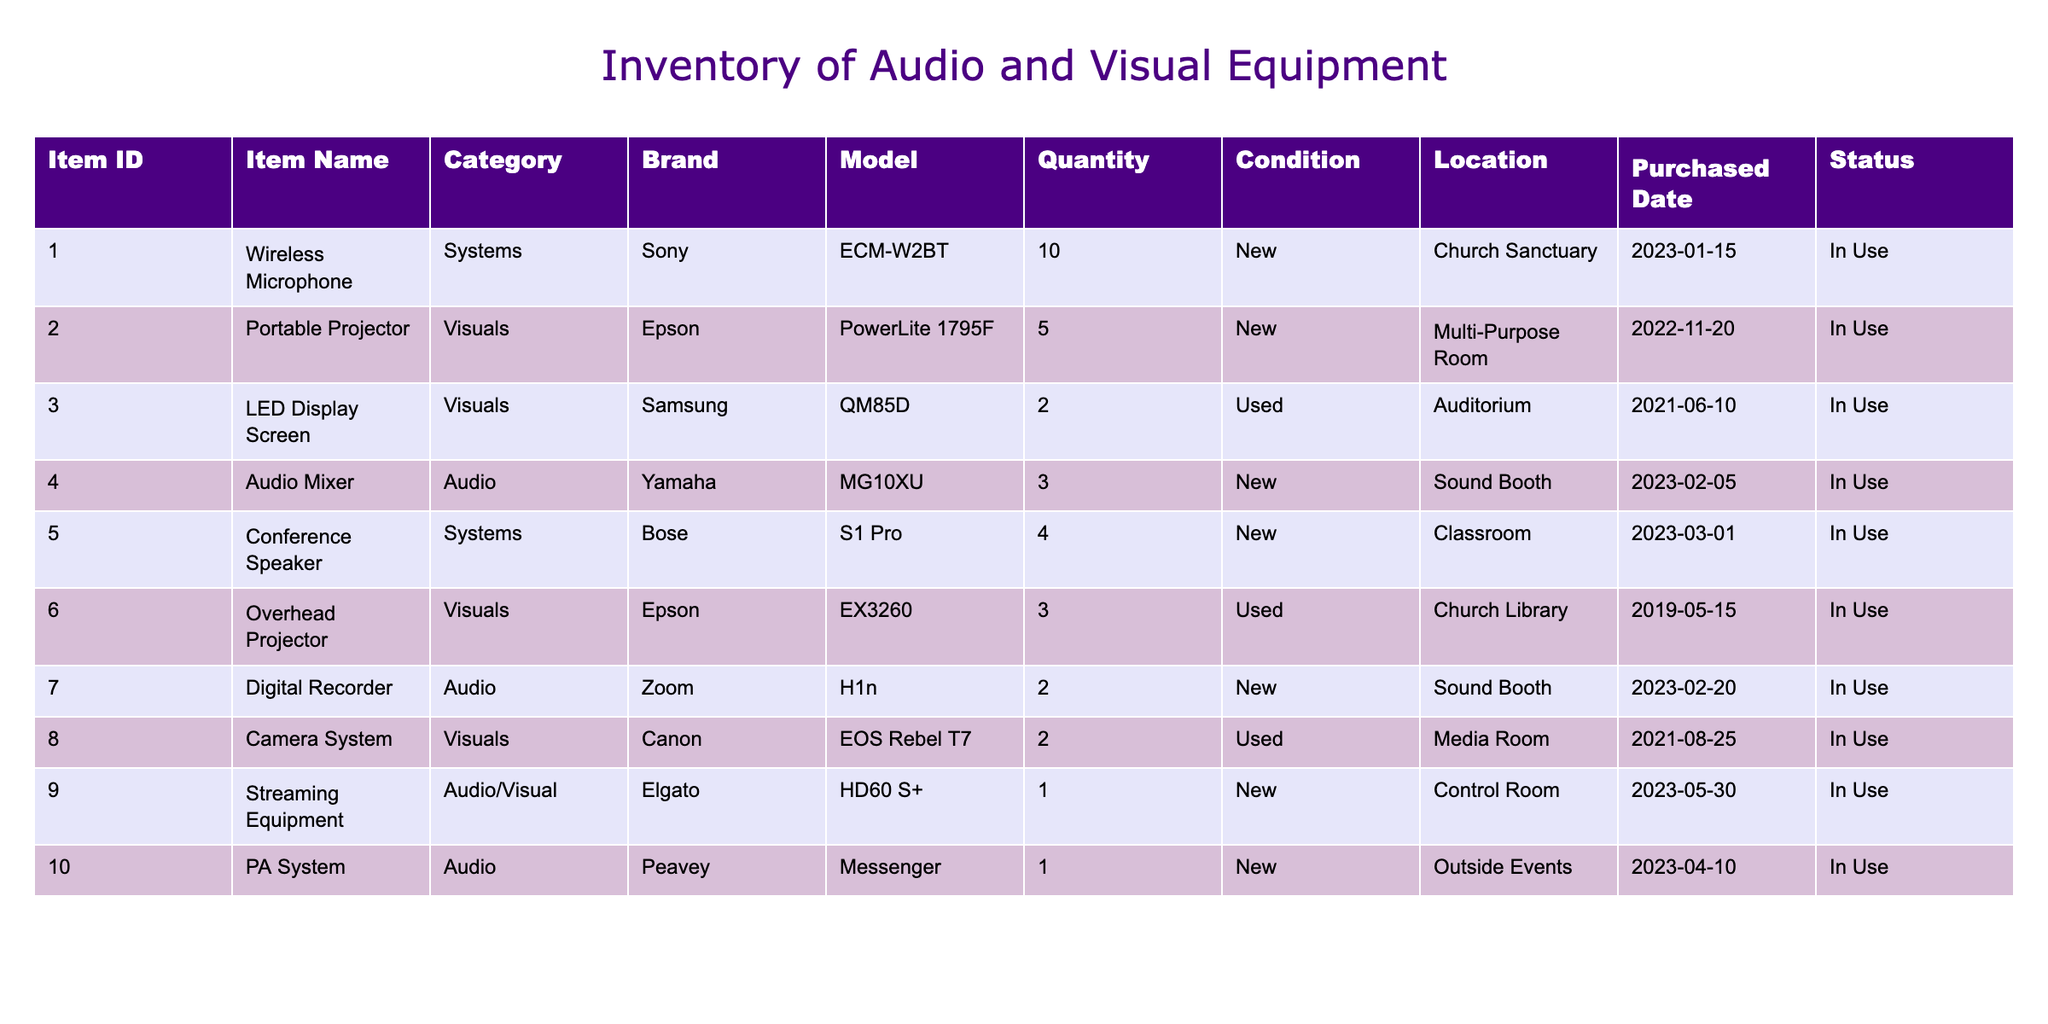What is the total quantity of audio equipment in the inventory? To find the total quantity of audio equipment, we need to sum the quantities of all items listed under the "Audio" category. The items in this category are: Audio Mixer with a quantity of 3, Digital Recorder with a quantity of 2, and PA System with a quantity of 1. So the total is 3 + 2 + 1 = 6.
Answer: 6 How many items are currently in use at the church? To determine how many items are in use, we count all items where the Status is "In Use." All 10 items listed in the table have this status, indicating that they are all currently being utilized.
Answer: 10 Is the camera system considered new or used? The Camera System has a listed condition of "Used," which indicates that it is not new. This conclusion is drawn directly from the "Condition" column in the table.
Answer: Used What is the average quantity of portable projectors per location? We know there are 5 Portable Projectors located in the Multi-Purpose Room. To find the average, we take the total quantity of 5 and divide it by the number of unique locations that have Portable Projectors, which is 1 (since they are all in the Multi-Purpose Room). Therefore, the calculation is 5 / 1 = 5.
Answer: 5 Do we have more new or used audio and visual equipment? To answer whether there are more new or used equipment, we count the number of items in each condition: New items are 8 (Wireless Microphone, Portable Projector, Audio Mixer, Conference Speaker, Digital Recorder, Streaming Equipment, PA System) and Used items are 3 (LED Display Screen, Overhead Projector, Camera System). Since 8 > 3, the answer is more.
Answer: More new equipment How many items were purchased in 2023? To find out how many items were purchased in 2023, we look at the "Purchased Date" column and count items dated within that year. The items with purchase dates in 2023 are Wireless Microphone, Audio Mixer, Digital Recorder, Streaming Equipment, and PA System, totaling 5 items.
Answer: 5 What percentage of the total inventory is in the "Systems" category? First, we need to count the total items, which is 10. The Systems category contains 2 items (Wireless Microphone and Conference Speaker). To get the percentage, we divide the number of items in that category (2) by the total (10) and multiply by 100: (2/10) * 100 = 20%.
Answer: 20% How many visual displays are located in the Auditorium? The only visual display in the table listed for the Auditorium is the LED Display Screen, which has a quantity of 2. Since it is the only entry for that location, we can conclude that there are 2 visual displays there.
Answer: 2 Is there any equipment with a condition listed as "Used"? Referring to the "Condition" column, the items listed as "Used" are the LED Display Screen, Overhead Projector, and Camera System. Since there are 3 items that meet this condition, the answer is yes.
Answer: Yes 